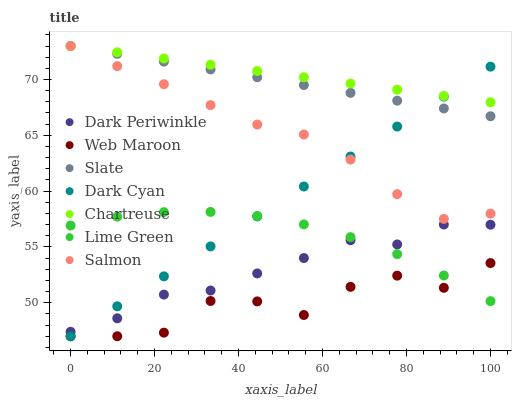Does Web Maroon have the minimum area under the curve?
Answer yes or no. Yes. Does Chartreuse have the maximum area under the curve?
Answer yes or no. Yes. Does Slate have the minimum area under the curve?
Answer yes or no. No. Does Slate have the maximum area under the curve?
Answer yes or no. No. Is Dark Cyan the smoothest?
Answer yes or no. Yes. Is Web Maroon the roughest?
Answer yes or no. Yes. Is Slate the smoothest?
Answer yes or no. No. Is Slate the roughest?
Answer yes or no. No. Does Web Maroon have the lowest value?
Answer yes or no. Yes. Does Slate have the lowest value?
Answer yes or no. No. Does Chartreuse have the highest value?
Answer yes or no. Yes. Does Web Maroon have the highest value?
Answer yes or no. No. Is Dark Periwinkle less than Salmon?
Answer yes or no. Yes. Is Salmon greater than Lime Green?
Answer yes or no. Yes. Does Dark Periwinkle intersect Dark Cyan?
Answer yes or no. Yes. Is Dark Periwinkle less than Dark Cyan?
Answer yes or no. No. Is Dark Periwinkle greater than Dark Cyan?
Answer yes or no. No. Does Dark Periwinkle intersect Salmon?
Answer yes or no. No. 